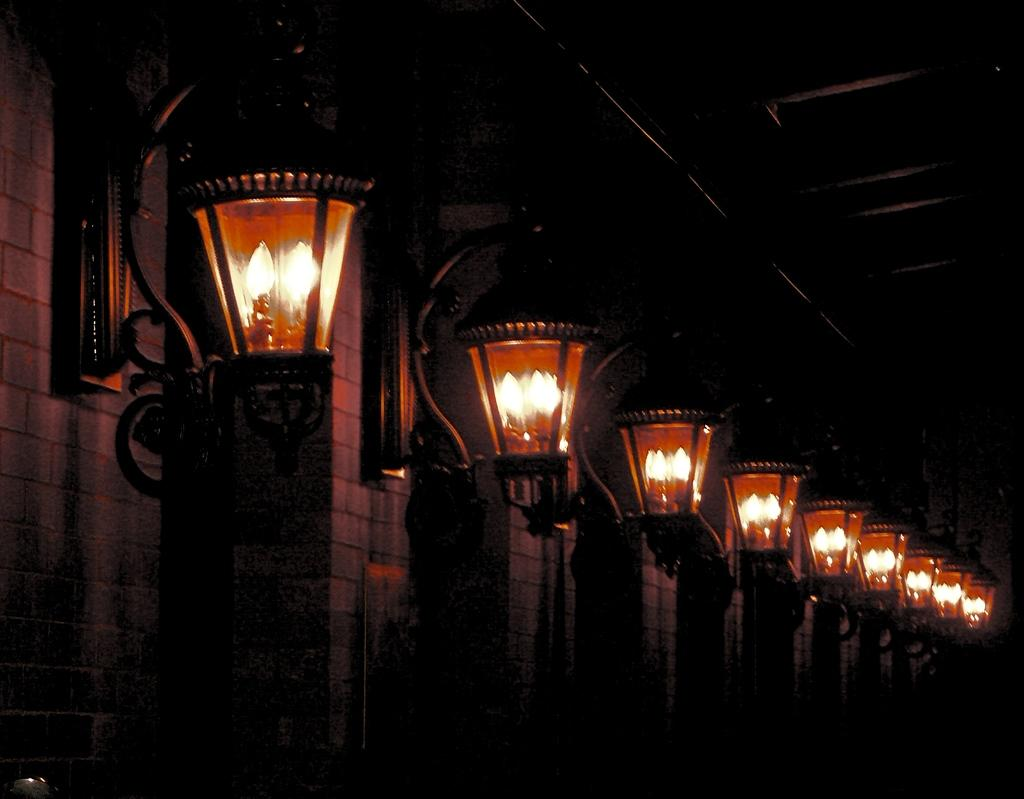What is located in the middle of the image? There are lights, a wall, and a roof in the middle of the image. Can you describe the lights in the image? The lights are in the middle of the image, but their specific type or function is not mentioned. What else is present in the middle of the image besides the lights? There is a wall and a roof in the middle of the image. What type of art can be seen on the wall in the image? There is no mention of any art on the wall in the image. Is the country visible in the image? The country is not mentioned or visible in the image. 